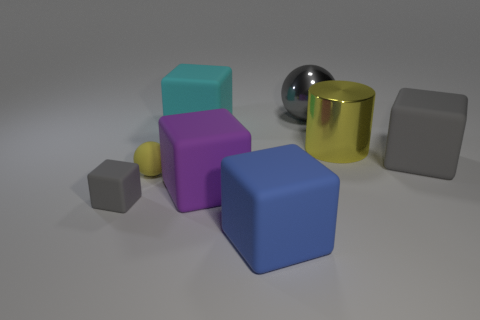How big is the object that is both on the left side of the large cyan thing and on the right side of the small gray cube?
Offer a very short reply. Small. How many other objects are the same shape as the purple matte thing?
Ensure brevity in your answer.  4. What number of other things are made of the same material as the big gray cube?
Offer a very short reply. 5. What size is the cyan matte thing that is the same shape as the big blue rubber object?
Provide a succinct answer. Large. Does the metal sphere have the same color as the tiny cube?
Your response must be concise. Yes. What is the color of the rubber cube that is right of the big purple rubber block and in front of the tiny yellow ball?
Your response must be concise. Blue. What number of objects are tiny things left of the small rubber ball or small gray matte balls?
Offer a very short reply. 1. What is the color of the small thing that is the same shape as the large gray metal object?
Provide a short and direct response. Yellow. There is a tiny gray rubber thing; is it the same shape as the yellow object in front of the big gray rubber block?
Offer a very short reply. No. How many things are either blocks in front of the large cylinder or large yellow metallic objects behind the large purple object?
Your answer should be very brief. 5. 